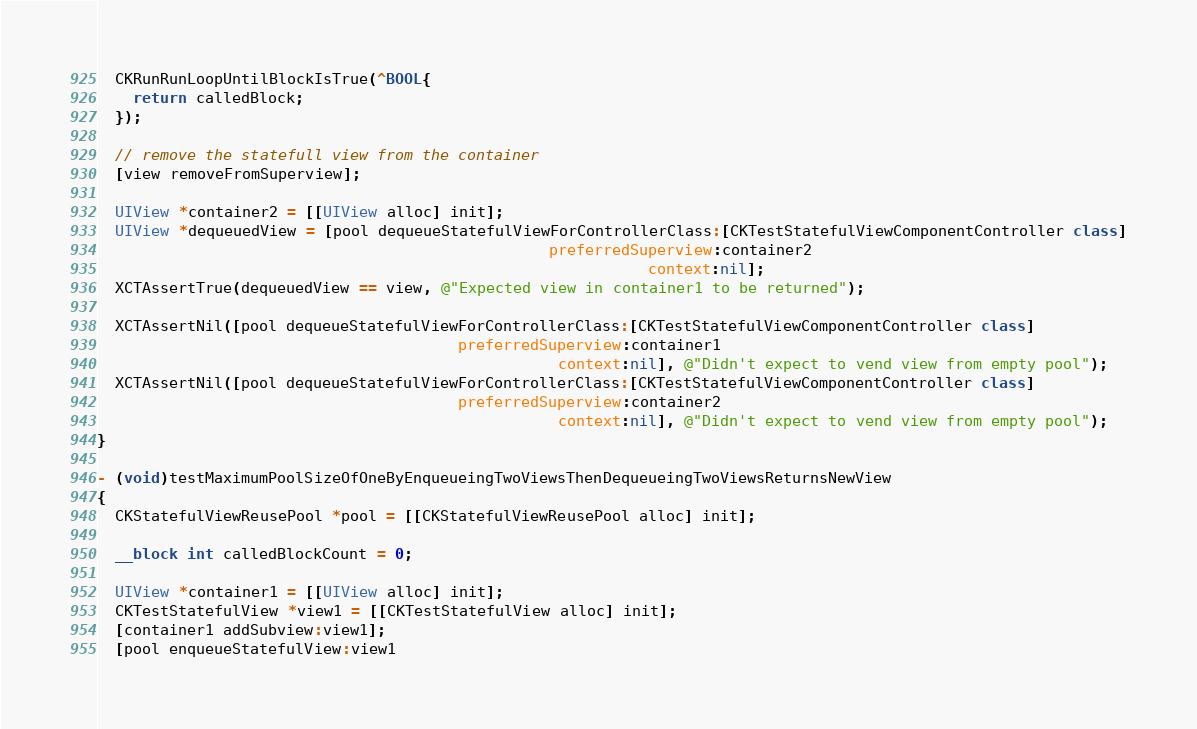<code> <loc_0><loc_0><loc_500><loc_500><_ObjectiveC_>  CKRunRunLoopUntilBlockIsTrue(^BOOL{
    return calledBlock;
  });

  // remove the statefull view from the container
  [view removeFromSuperview];

  UIView *container2 = [[UIView alloc] init];
  UIView *dequeuedView = [pool dequeueStatefulViewForControllerClass:[CKTestStatefulViewComponentController class]
                                                  preferredSuperview:container2
                                                             context:nil];
  XCTAssertTrue(dequeuedView == view, @"Expected view in container1 to be returned");

  XCTAssertNil([pool dequeueStatefulViewForControllerClass:[CKTestStatefulViewComponentController class]
                                        preferredSuperview:container1
                                                   context:nil], @"Didn't expect to vend view from empty pool");
  XCTAssertNil([pool dequeueStatefulViewForControllerClass:[CKTestStatefulViewComponentController class]
                                        preferredSuperview:container2
                                                   context:nil], @"Didn't expect to vend view from empty pool");
}

- (void)testMaximumPoolSizeOfOneByEnqueueingTwoViewsThenDequeueingTwoViewsReturnsNewView
{
  CKStatefulViewReusePool *pool = [[CKStatefulViewReusePool alloc] init];

  __block int calledBlockCount = 0;

  UIView *container1 = [[UIView alloc] init];
  CKTestStatefulView *view1 = [[CKTestStatefulView alloc] init];
  [container1 addSubview:view1];
  [pool enqueueStatefulView:view1</code> 